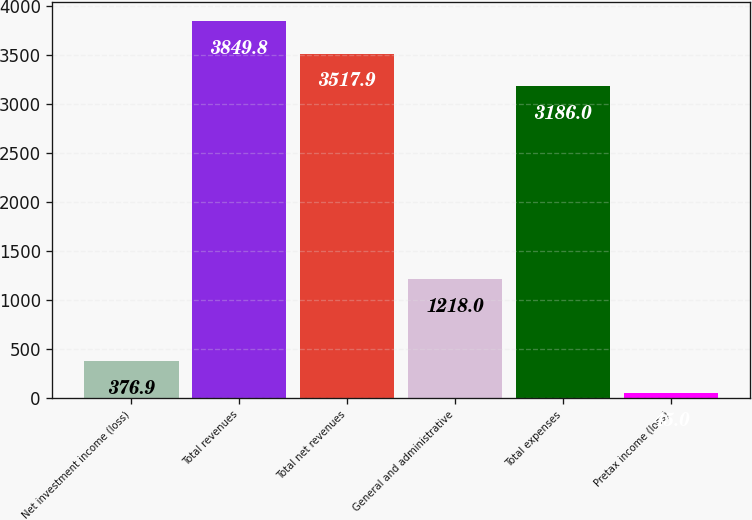<chart> <loc_0><loc_0><loc_500><loc_500><bar_chart><fcel>Net investment income (loss)<fcel>Total revenues<fcel>Total net revenues<fcel>General and administrative<fcel>Total expenses<fcel>Pretax income (loss)<nl><fcel>376.9<fcel>3849.8<fcel>3517.9<fcel>1218<fcel>3186<fcel>45<nl></chart> 